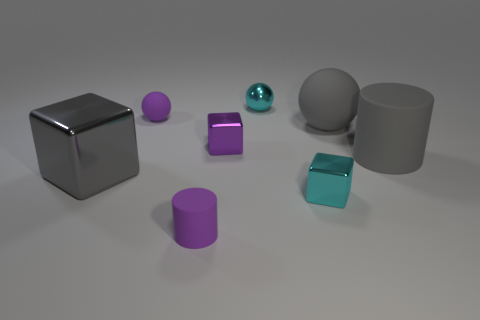Can you describe the lighting in the scene, and how it may affect the mood or atmosphere? The lighting in the scene is soft and diffused, creating gentle shadows and subtle reflections. There are no harsh highlights or deep shadows, which suggests a calm, neutral mood. The environment seems to be uniformly lit, which might indicate an indoor setting with controlled lighting, such as a studio. The overall impact of this lighting is one of clarity and serenity, with the focus being on the shapes and textures of the objects rather than the atmosphere or emotional tone. 